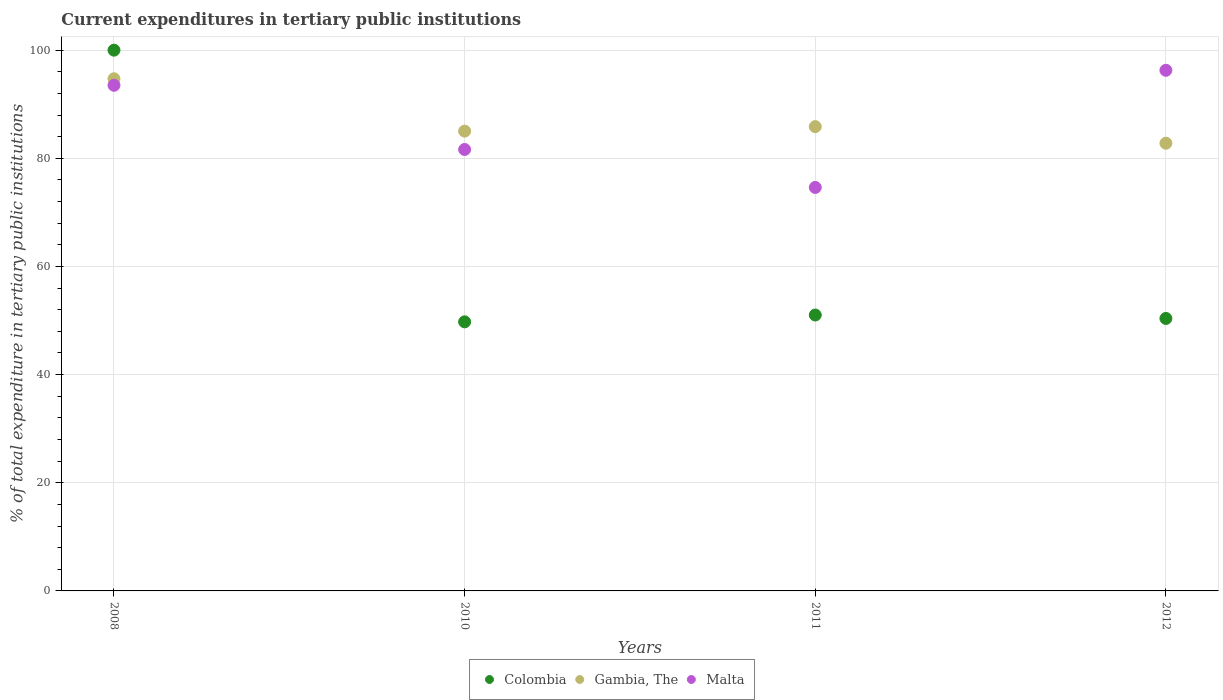How many different coloured dotlines are there?
Provide a short and direct response. 3. What is the current expenditures in tertiary public institutions in Malta in 2012?
Provide a succinct answer. 96.28. Across all years, what is the maximum current expenditures in tertiary public institutions in Colombia?
Provide a short and direct response. 100. Across all years, what is the minimum current expenditures in tertiary public institutions in Gambia, The?
Offer a terse response. 82.79. What is the total current expenditures in tertiary public institutions in Colombia in the graph?
Provide a succinct answer. 251.16. What is the difference between the current expenditures in tertiary public institutions in Colombia in 2011 and that in 2012?
Provide a short and direct response. 0.63. What is the difference between the current expenditures in tertiary public institutions in Colombia in 2011 and the current expenditures in tertiary public institutions in Gambia, The in 2008?
Ensure brevity in your answer.  -43.69. What is the average current expenditures in tertiary public institutions in Malta per year?
Provide a succinct answer. 86.51. In the year 2008, what is the difference between the current expenditures in tertiary public institutions in Malta and current expenditures in tertiary public institutions in Gambia, The?
Provide a succinct answer. -1.2. In how many years, is the current expenditures in tertiary public institutions in Colombia greater than 84 %?
Offer a very short reply. 1. What is the ratio of the current expenditures in tertiary public institutions in Gambia, The in 2011 to that in 2012?
Provide a short and direct response. 1.04. Is the difference between the current expenditures in tertiary public institutions in Malta in 2010 and 2012 greater than the difference between the current expenditures in tertiary public institutions in Gambia, The in 2010 and 2012?
Provide a succinct answer. No. What is the difference between the highest and the second highest current expenditures in tertiary public institutions in Gambia, The?
Your response must be concise. 8.85. What is the difference between the highest and the lowest current expenditures in tertiary public institutions in Gambia, The?
Your answer should be very brief. 11.92. Is the current expenditures in tertiary public institutions in Malta strictly less than the current expenditures in tertiary public institutions in Colombia over the years?
Offer a terse response. No. How many dotlines are there?
Offer a terse response. 3. What is the difference between two consecutive major ticks on the Y-axis?
Your answer should be very brief. 20. Are the values on the major ticks of Y-axis written in scientific E-notation?
Ensure brevity in your answer.  No. Does the graph contain any zero values?
Offer a very short reply. No. How many legend labels are there?
Give a very brief answer. 3. What is the title of the graph?
Provide a short and direct response. Current expenditures in tertiary public institutions. What is the label or title of the Y-axis?
Offer a very short reply. % of total expenditure in tertiary public institutions. What is the % of total expenditure in tertiary public institutions in Gambia, The in 2008?
Your answer should be compact. 94.71. What is the % of total expenditure in tertiary public institutions in Malta in 2008?
Your response must be concise. 93.5. What is the % of total expenditure in tertiary public institutions in Colombia in 2010?
Offer a terse response. 49.76. What is the % of total expenditure in tertiary public institutions in Gambia, The in 2010?
Your response must be concise. 85.03. What is the % of total expenditure in tertiary public institutions in Malta in 2010?
Your answer should be compact. 81.63. What is the % of total expenditure in tertiary public institutions of Colombia in 2011?
Offer a very short reply. 51.02. What is the % of total expenditure in tertiary public institutions of Gambia, The in 2011?
Provide a succinct answer. 85.86. What is the % of total expenditure in tertiary public institutions of Malta in 2011?
Offer a terse response. 74.62. What is the % of total expenditure in tertiary public institutions in Colombia in 2012?
Ensure brevity in your answer.  50.39. What is the % of total expenditure in tertiary public institutions of Gambia, The in 2012?
Make the answer very short. 82.79. What is the % of total expenditure in tertiary public institutions in Malta in 2012?
Offer a terse response. 96.28. Across all years, what is the maximum % of total expenditure in tertiary public institutions of Colombia?
Ensure brevity in your answer.  100. Across all years, what is the maximum % of total expenditure in tertiary public institutions in Gambia, The?
Your response must be concise. 94.71. Across all years, what is the maximum % of total expenditure in tertiary public institutions of Malta?
Your answer should be very brief. 96.28. Across all years, what is the minimum % of total expenditure in tertiary public institutions in Colombia?
Offer a very short reply. 49.76. Across all years, what is the minimum % of total expenditure in tertiary public institutions in Gambia, The?
Keep it short and to the point. 82.79. Across all years, what is the minimum % of total expenditure in tertiary public institutions of Malta?
Your answer should be compact. 74.62. What is the total % of total expenditure in tertiary public institutions in Colombia in the graph?
Make the answer very short. 251.16. What is the total % of total expenditure in tertiary public institutions of Gambia, The in the graph?
Offer a terse response. 348.38. What is the total % of total expenditure in tertiary public institutions in Malta in the graph?
Your answer should be compact. 346.03. What is the difference between the % of total expenditure in tertiary public institutions of Colombia in 2008 and that in 2010?
Ensure brevity in your answer.  50.24. What is the difference between the % of total expenditure in tertiary public institutions in Gambia, The in 2008 and that in 2010?
Make the answer very short. 9.68. What is the difference between the % of total expenditure in tertiary public institutions of Malta in 2008 and that in 2010?
Your answer should be very brief. 11.87. What is the difference between the % of total expenditure in tertiary public institutions of Colombia in 2008 and that in 2011?
Provide a short and direct response. 48.98. What is the difference between the % of total expenditure in tertiary public institutions in Gambia, The in 2008 and that in 2011?
Offer a very short reply. 8.85. What is the difference between the % of total expenditure in tertiary public institutions of Malta in 2008 and that in 2011?
Your answer should be compact. 18.89. What is the difference between the % of total expenditure in tertiary public institutions in Colombia in 2008 and that in 2012?
Provide a short and direct response. 49.61. What is the difference between the % of total expenditure in tertiary public institutions of Gambia, The in 2008 and that in 2012?
Offer a very short reply. 11.92. What is the difference between the % of total expenditure in tertiary public institutions in Malta in 2008 and that in 2012?
Ensure brevity in your answer.  -2.77. What is the difference between the % of total expenditure in tertiary public institutions of Colombia in 2010 and that in 2011?
Your answer should be compact. -1.26. What is the difference between the % of total expenditure in tertiary public institutions in Gambia, The in 2010 and that in 2011?
Make the answer very short. -0.83. What is the difference between the % of total expenditure in tertiary public institutions of Malta in 2010 and that in 2011?
Your answer should be very brief. 7.02. What is the difference between the % of total expenditure in tertiary public institutions in Colombia in 2010 and that in 2012?
Offer a terse response. -0.63. What is the difference between the % of total expenditure in tertiary public institutions of Gambia, The in 2010 and that in 2012?
Keep it short and to the point. 2.24. What is the difference between the % of total expenditure in tertiary public institutions in Malta in 2010 and that in 2012?
Offer a very short reply. -14.64. What is the difference between the % of total expenditure in tertiary public institutions of Colombia in 2011 and that in 2012?
Provide a short and direct response. 0.63. What is the difference between the % of total expenditure in tertiary public institutions in Gambia, The in 2011 and that in 2012?
Your answer should be very brief. 3.07. What is the difference between the % of total expenditure in tertiary public institutions in Malta in 2011 and that in 2012?
Provide a succinct answer. -21.66. What is the difference between the % of total expenditure in tertiary public institutions of Colombia in 2008 and the % of total expenditure in tertiary public institutions of Gambia, The in 2010?
Provide a succinct answer. 14.97. What is the difference between the % of total expenditure in tertiary public institutions of Colombia in 2008 and the % of total expenditure in tertiary public institutions of Malta in 2010?
Your answer should be very brief. 18.37. What is the difference between the % of total expenditure in tertiary public institutions in Gambia, The in 2008 and the % of total expenditure in tertiary public institutions in Malta in 2010?
Make the answer very short. 13.07. What is the difference between the % of total expenditure in tertiary public institutions in Colombia in 2008 and the % of total expenditure in tertiary public institutions in Gambia, The in 2011?
Give a very brief answer. 14.14. What is the difference between the % of total expenditure in tertiary public institutions of Colombia in 2008 and the % of total expenditure in tertiary public institutions of Malta in 2011?
Provide a short and direct response. 25.38. What is the difference between the % of total expenditure in tertiary public institutions of Gambia, The in 2008 and the % of total expenditure in tertiary public institutions of Malta in 2011?
Offer a terse response. 20.09. What is the difference between the % of total expenditure in tertiary public institutions in Colombia in 2008 and the % of total expenditure in tertiary public institutions in Gambia, The in 2012?
Offer a terse response. 17.21. What is the difference between the % of total expenditure in tertiary public institutions in Colombia in 2008 and the % of total expenditure in tertiary public institutions in Malta in 2012?
Your answer should be very brief. 3.72. What is the difference between the % of total expenditure in tertiary public institutions in Gambia, The in 2008 and the % of total expenditure in tertiary public institutions in Malta in 2012?
Ensure brevity in your answer.  -1.57. What is the difference between the % of total expenditure in tertiary public institutions of Colombia in 2010 and the % of total expenditure in tertiary public institutions of Gambia, The in 2011?
Your answer should be very brief. -36.1. What is the difference between the % of total expenditure in tertiary public institutions of Colombia in 2010 and the % of total expenditure in tertiary public institutions of Malta in 2011?
Give a very brief answer. -24.86. What is the difference between the % of total expenditure in tertiary public institutions in Gambia, The in 2010 and the % of total expenditure in tertiary public institutions in Malta in 2011?
Your answer should be compact. 10.41. What is the difference between the % of total expenditure in tertiary public institutions in Colombia in 2010 and the % of total expenditure in tertiary public institutions in Gambia, The in 2012?
Ensure brevity in your answer.  -33.03. What is the difference between the % of total expenditure in tertiary public institutions in Colombia in 2010 and the % of total expenditure in tertiary public institutions in Malta in 2012?
Provide a short and direct response. -46.52. What is the difference between the % of total expenditure in tertiary public institutions in Gambia, The in 2010 and the % of total expenditure in tertiary public institutions in Malta in 2012?
Offer a very short reply. -11.25. What is the difference between the % of total expenditure in tertiary public institutions of Colombia in 2011 and the % of total expenditure in tertiary public institutions of Gambia, The in 2012?
Your answer should be compact. -31.77. What is the difference between the % of total expenditure in tertiary public institutions of Colombia in 2011 and the % of total expenditure in tertiary public institutions of Malta in 2012?
Offer a terse response. -45.26. What is the difference between the % of total expenditure in tertiary public institutions of Gambia, The in 2011 and the % of total expenditure in tertiary public institutions of Malta in 2012?
Ensure brevity in your answer.  -10.42. What is the average % of total expenditure in tertiary public institutions of Colombia per year?
Your answer should be compact. 62.79. What is the average % of total expenditure in tertiary public institutions of Gambia, The per year?
Provide a short and direct response. 87.1. What is the average % of total expenditure in tertiary public institutions of Malta per year?
Offer a terse response. 86.51. In the year 2008, what is the difference between the % of total expenditure in tertiary public institutions in Colombia and % of total expenditure in tertiary public institutions in Gambia, The?
Your answer should be compact. 5.29. In the year 2008, what is the difference between the % of total expenditure in tertiary public institutions of Colombia and % of total expenditure in tertiary public institutions of Malta?
Your answer should be compact. 6.5. In the year 2008, what is the difference between the % of total expenditure in tertiary public institutions of Gambia, The and % of total expenditure in tertiary public institutions of Malta?
Give a very brief answer. 1.2. In the year 2010, what is the difference between the % of total expenditure in tertiary public institutions in Colombia and % of total expenditure in tertiary public institutions in Gambia, The?
Give a very brief answer. -35.27. In the year 2010, what is the difference between the % of total expenditure in tertiary public institutions in Colombia and % of total expenditure in tertiary public institutions in Malta?
Make the answer very short. -31.87. In the year 2010, what is the difference between the % of total expenditure in tertiary public institutions in Gambia, The and % of total expenditure in tertiary public institutions in Malta?
Provide a succinct answer. 3.39. In the year 2011, what is the difference between the % of total expenditure in tertiary public institutions of Colombia and % of total expenditure in tertiary public institutions of Gambia, The?
Your response must be concise. -34.84. In the year 2011, what is the difference between the % of total expenditure in tertiary public institutions of Colombia and % of total expenditure in tertiary public institutions of Malta?
Your response must be concise. -23.6. In the year 2011, what is the difference between the % of total expenditure in tertiary public institutions of Gambia, The and % of total expenditure in tertiary public institutions of Malta?
Make the answer very short. 11.24. In the year 2012, what is the difference between the % of total expenditure in tertiary public institutions in Colombia and % of total expenditure in tertiary public institutions in Gambia, The?
Make the answer very short. -32.4. In the year 2012, what is the difference between the % of total expenditure in tertiary public institutions in Colombia and % of total expenditure in tertiary public institutions in Malta?
Ensure brevity in your answer.  -45.89. In the year 2012, what is the difference between the % of total expenditure in tertiary public institutions in Gambia, The and % of total expenditure in tertiary public institutions in Malta?
Provide a succinct answer. -13.49. What is the ratio of the % of total expenditure in tertiary public institutions of Colombia in 2008 to that in 2010?
Your answer should be very brief. 2.01. What is the ratio of the % of total expenditure in tertiary public institutions of Gambia, The in 2008 to that in 2010?
Offer a very short reply. 1.11. What is the ratio of the % of total expenditure in tertiary public institutions of Malta in 2008 to that in 2010?
Your answer should be very brief. 1.15. What is the ratio of the % of total expenditure in tertiary public institutions in Colombia in 2008 to that in 2011?
Keep it short and to the point. 1.96. What is the ratio of the % of total expenditure in tertiary public institutions of Gambia, The in 2008 to that in 2011?
Your answer should be compact. 1.1. What is the ratio of the % of total expenditure in tertiary public institutions of Malta in 2008 to that in 2011?
Offer a terse response. 1.25. What is the ratio of the % of total expenditure in tertiary public institutions in Colombia in 2008 to that in 2012?
Give a very brief answer. 1.98. What is the ratio of the % of total expenditure in tertiary public institutions of Gambia, The in 2008 to that in 2012?
Your response must be concise. 1.14. What is the ratio of the % of total expenditure in tertiary public institutions of Malta in 2008 to that in 2012?
Offer a terse response. 0.97. What is the ratio of the % of total expenditure in tertiary public institutions in Colombia in 2010 to that in 2011?
Provide a short and direct response. 0.98. What is the ratio of the % of total expenditure in tertiary public institutions of Gambia, The in 2010 to that in 2011?
Your answer should be compact. 0.99. What is the ratio of the % of total expenditure in tertiary public institutions of Malta in 2010 to that in 2011?
Ensure brevity in your answer.  1.09. What is the ratio of the % of total expenditure in tertiary public institutions in Colombia in 2010 to that in 2012?
Your answer should be very brief. 0.99. What is the ratio of the % of total expenditure in tertiary public institutions in Malta in 2010 to that in 2012?
Your response must be concise. 0.85. What is the ratio of the % of total expenditure in tertiary public institutions of Colombia in 2011 to that in 2012?
Your answer should be very brief. 1.01. What is the ratio of the % of total expenditure in tertiary public institutions in Malta in 2011 to that in 2012?
Provide a short and direct response. 0.78. What is the difference between the highest and the second highest % of total expenditure in tertiary public institutions of Colombia?
Offer a terse response. 48.98. What is the difference between the highest and the second highest % of total expenditure in tertiary public institutions in Gambia, The?
Provide a short and direct response. 8.85. What is the difference between the highest and the second highest % of total expenditure in tertiary public institutions in Malta?
Offer a terse response. 2.77. What is the difference between the highest and the lowest % of total expenditure in tertiary public institutions of Colombia?
Give a very brief answer. 50.24. What is the difference between the highest and the lowest % of total expenditure in tertiary public institutions of Gambia, The?
Provide a succinct answer. 11.92. What is the difference between the highest and the lowest % of total expenditure in tertiary public institutions of Malta?
Your answer should be very brief. 21.66. 